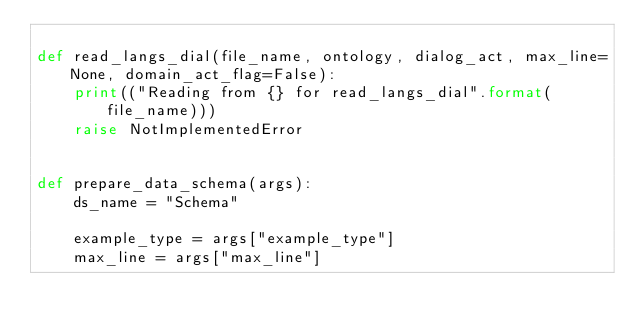Convert code to text. <code><loc_0><loc_0><loc_500><loc_500><_Python_>
def read_langs_dial(file_name, ontology, dialog_act, max_line=None, domain_act_flag=False):
    print(("Reading from {} for read_langs_dial".format(file_name)))
    raise NotImplementedError


def prepare_data_schema(args):
    ds_name = "Schema"

    example_type = args["example_type"]
    max_line = args["max_line"]
</code> 